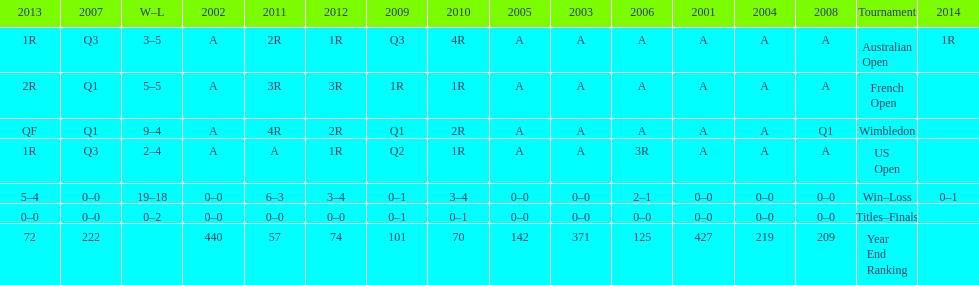In which years were there only 1 loss? 2006, 2009, 2014. 